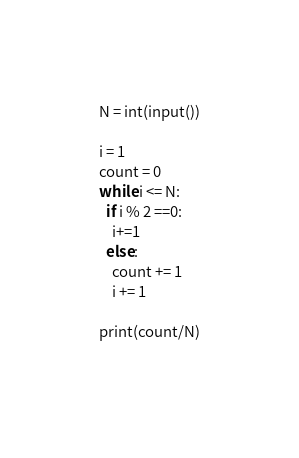<code> <loc_0><loc_0><loc_500><loc_500><_Python_>N = int(input())

i = 1
count = 0
while i <= N:
  if i % 2 ==0:
    i+=1
  else:
    count += 1
    i += 1
    
print(count/N)
    </code> 